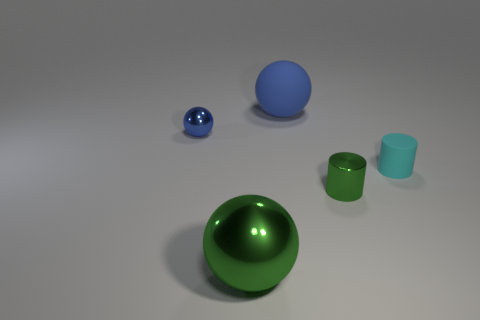Subtract all rubber spheres. How many spheres are left? 2 Add 2 large yellow metal cubes. How many objects exist? 7 Subtract all green spheres. How many spheres are left? 2 Subtract all cyan cylinders. Subtract all tiny green shiny things. How many objects are left? 3 Add 5 tiny blue spheres. How many tiny blue spheres are left? 6 Add 3 blue objects. How many blue objects exist? 5 Subtract 1 blue spheres. How many objects are left? 4 Subtract all cylinders. How many objects are left? 3 Subtract 2 cylinders. How many cylinders are left? 0 Subtract all gray balls. Subtract all brown blocks. How many balls are left? 3 